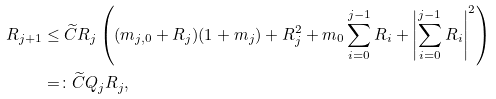Convert formula to latex. <formula><loc_0><loc_0><loc_500><loc_500>R _ { j + 1 } & \leq \widetilde { C } R _ { j } \left ( ( m _ { j , 0 } + R _ { j } ) ( 1 + m _ { j } ) + R _ { j } ^ { 2 } + m _ { 0 } \sum _ { i = 0 } ^ { j - 1 } R _ { i } + \left | \sum _ { i = 0 } ^ { j - 1 } R _ { i } \right | ^ { 2 } \right ) \\ & = \colon \widetilde { C } Q _ { j } R _ { j } ,</formula> 